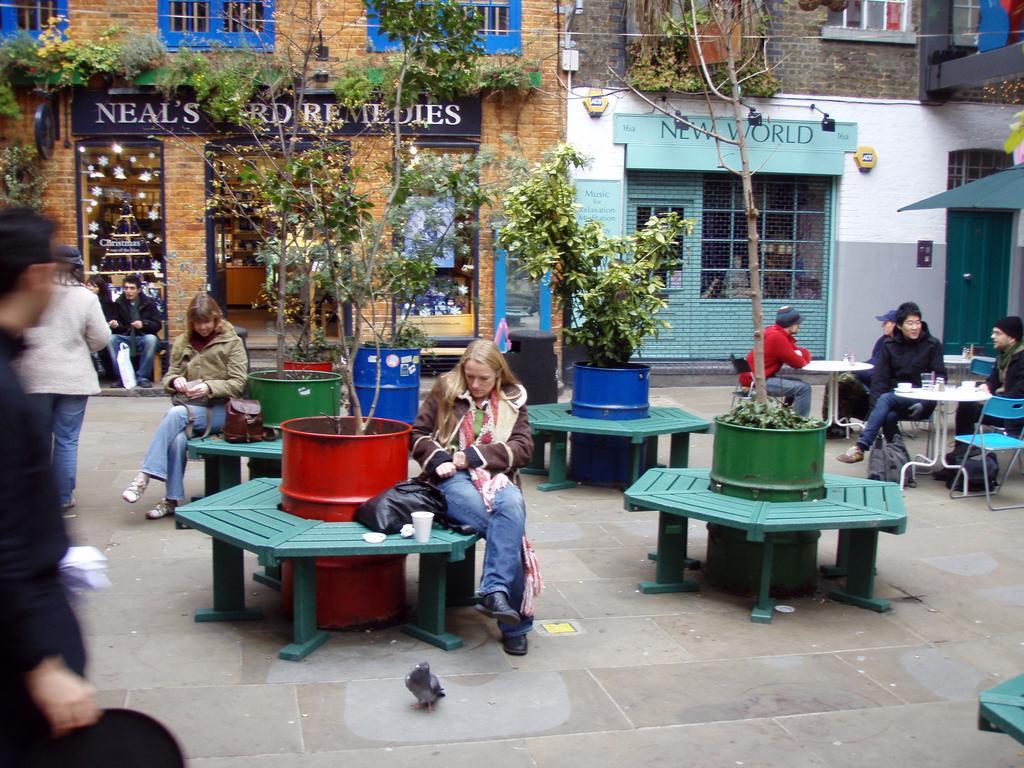In one or two sentences, can you explain what this image depicts? This is a picture which is clicked outside the city. In this picture, we see four green tables inside which four drums are placed. On the right corner of the picture, we see dining tables on which cup, saucer, glass are placed. Here, we see many people in this image. Behind these drums, we see a building with name written on it. On the right of that, we see green color building. On top of it, it is written as 'new world'. 